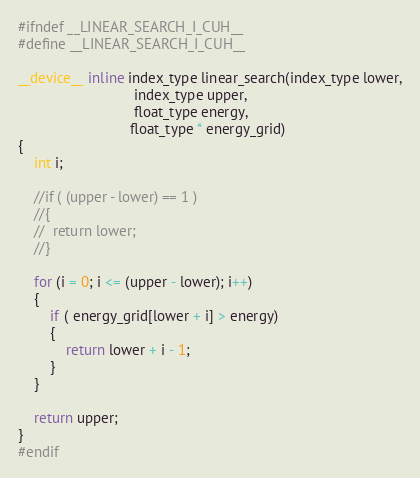Convert code to text. <code><loc_0><loc_0><loc_500><loc_500><_Cuda_>#ifndef __LINEAR_SEARCH_I_CUH__
#define __LINEAR_SEARCH_I_CUH__

__device__ inline index_type linear_search(index_type lower,
							 index_type upper,
							 float_type energy,
							float_type * energy_grid)
{
	int i;

	//if ( (upper - lower) == 1 )
	//{
	//	return lower;
	//}

	for (i = 0; i <= (upper - lower); i++)
	{
		if ( energy_grid[lower + i] > energy)
		{
			return lower + i - 1;
		}
	}

	return upper;
}
#endif
</code> 